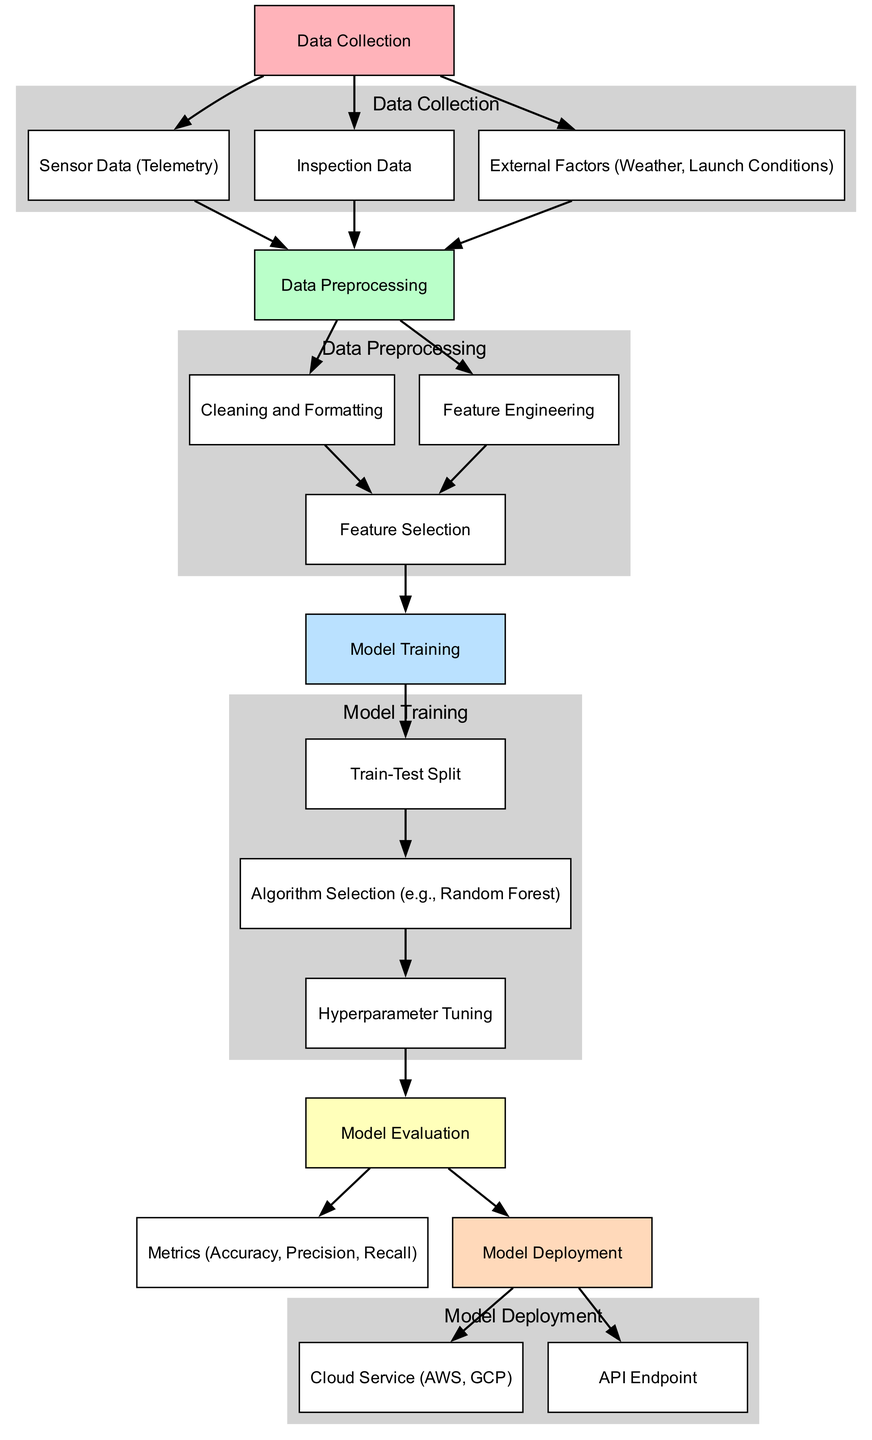What is the first step in the pipeline? The diagram shows that the first step is labeled "Data Collection", which is the starting point before any processing or modeling occurs.
Answer: Data Collection How many data collection sources are there? The diagram indicates three sources of data collection: Sensor Data, Inspection Data, and External Factors, which are all part of the first step.
Answer: Three Which node comes directly after Data Preprocessing? Following the Data Preprocessing step, the next node is labeled "Cleaning and Formatting", indicating the processes involved after data is collected.
Answer: Cleaning and Formatting What are the metrics used for model evaluation? The metrics provided in the diagram as part of the Model Evaluation step include Accuracy, Precision, and Recall, which are common measures of a model's performance.
Answer: Accuracy, Precision, Recall What is the last step in the pipeline before deployment? The last step before deployment, according to the diagram, is "Model Evaluation", where the model's effectiveness is assessed before it is moved to deployment.
Answer: Model Evaluation After which step does Feature Selection occur? Feature Selection is performed after both Feature Engineering and Cleaning and Formatting, as indicated in the flow of the diagram connecting those nodes.
Answer: After cleaning and formatting, after feature engineering How is Model Deployment achieved according to the diagram? Model Deployment occurs through two routes: utilizing a Cloud Service and providing an API Endpoint, both of which indicate how the model will be made available for use after training and evaluation.
Answer: Cloud Service and API Endpoint Which algorithms are suggested for selection in the diagram? The diagram specifies "Algorithm Selection (e.g., Random Forest)" as part of the model training phase, indicating that Random Forest is an example of the algorithms used.
Answer: Random Forest What color represents the data preprocessing phase in the diagram? In the diagram, the data preprocessing phase is represented in light green, as shown by the color coding for that section.
Answer: Light green How many nodes are in the Model Deployment phase? The Model Deployment phase has two nodes: Cloud Service and API Endpoint, which describe the options for deploying the model.
Answer: Two 